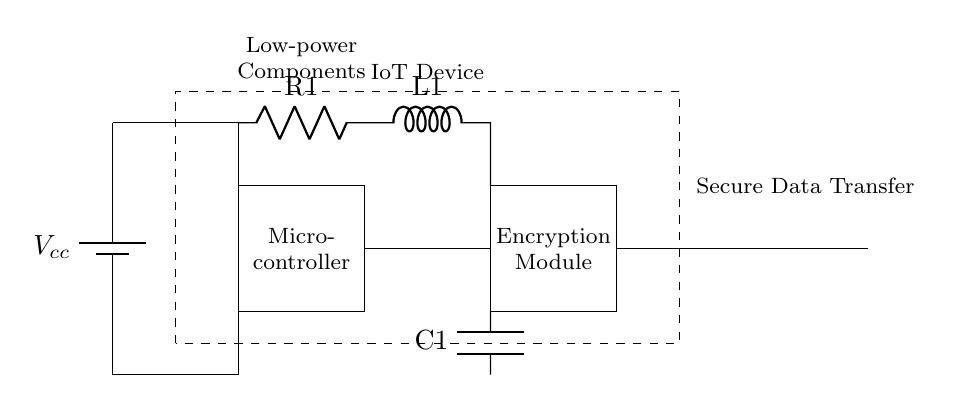What is the voltage source used in this circuit? The diagram shows a battery labeled as Vcc, which is the voltage source providing power to the circuit.
Answer: Vcc What type of component is used for data encryption? The circuit includes a rectangular block labeled as the "Encryption Module," which indicates the presence of an encryption component.
Answer: Encryption Module What are the passive components in the circuit? The circuit diagram shows a resistor labeled as R1, an inductor labeled as L1, and a capacitor labeled as C1, all of which are passive components.
Answer: R1, L1, C1 What is the purpose of the antenna in the circuit? The antenna is specifically included in the diagram for indicating wireless communication, likely for transferring data securely, as suggested by the labels in the diagram.
Answer: Wireless communication How are the microcontroller and encryption module connected? The microcontroller is connected to the encryption module through a direct line, showing they are likely communicating and passing data between each other.
Answer: Direct line connection What is the total number of components shown in the IoT device? By counting the distinct parts in the diagram, including the microcontroller, encryption module, antenna, and passive components, we find a total of five components shown in the IoT device.
Answer: Five 